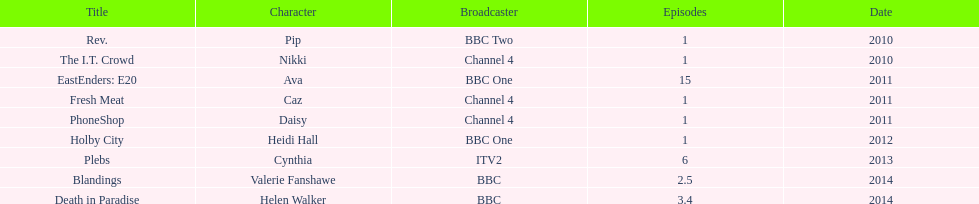How many television credits does this actress have? 9. 